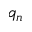<formula> <loc_0><loc_0><loc_500><loc_500>q _ { n }</formula> 